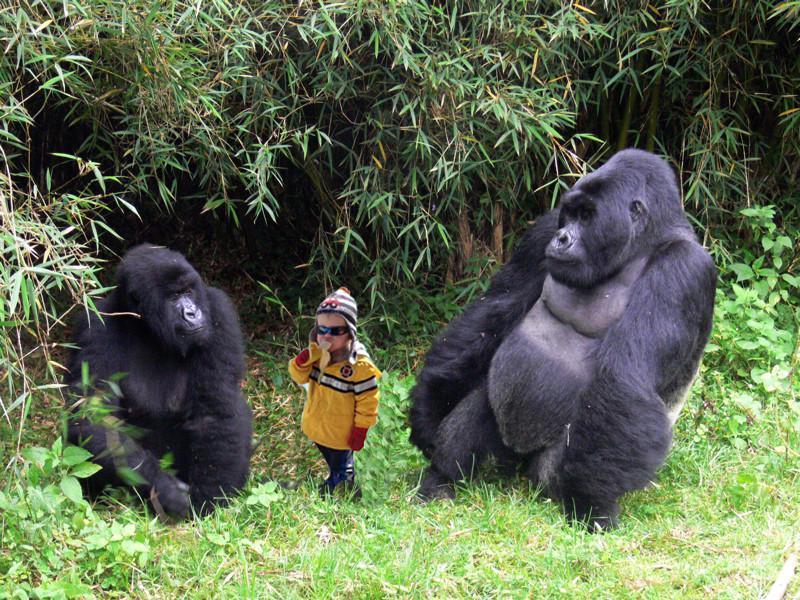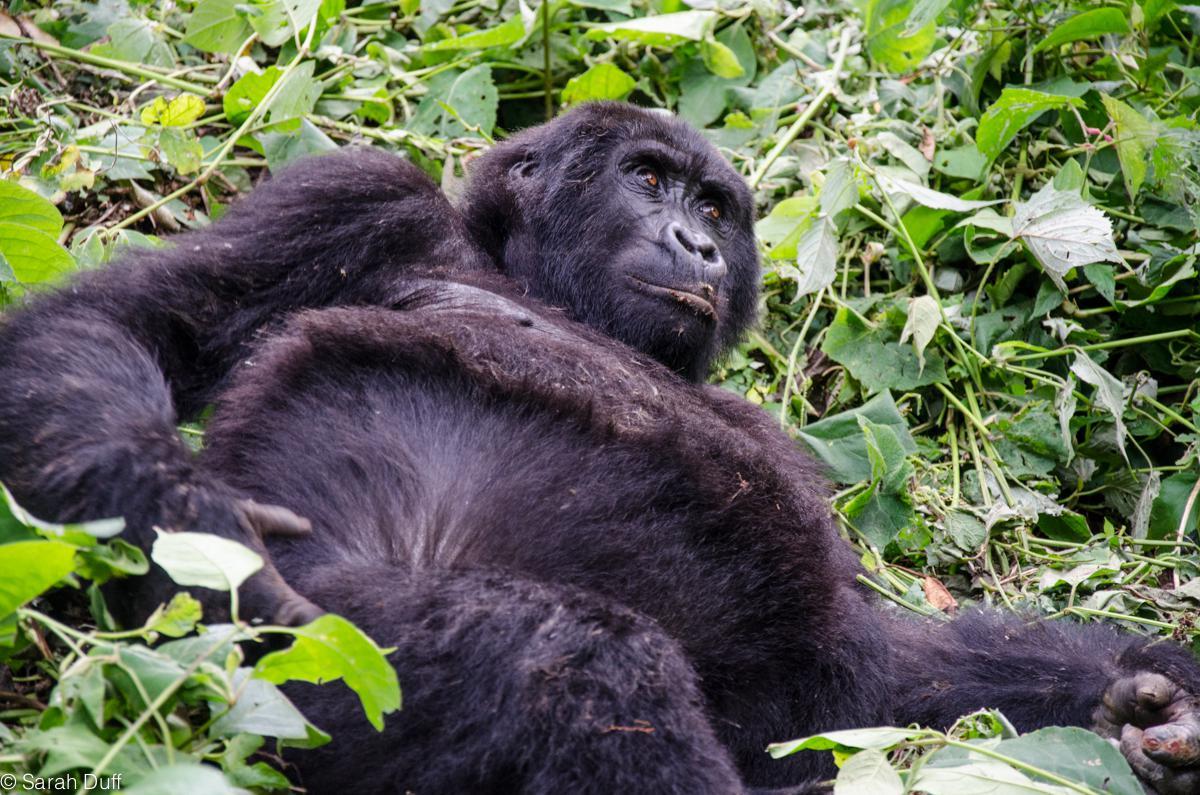The first image is the image on the left, the second image is the image on the right. Evaluate the accuracy of this statement regarding the images: "There are more than three apes visible, whether in foreground or background.". Is it true? Answer yes or no. No. The first image is the image on the left, the second image is the image on the right. Examine the images to the left and right. Is the description "There are exactly three gorillas in the pair of images." accurate? Answer yes or no. Yes. 